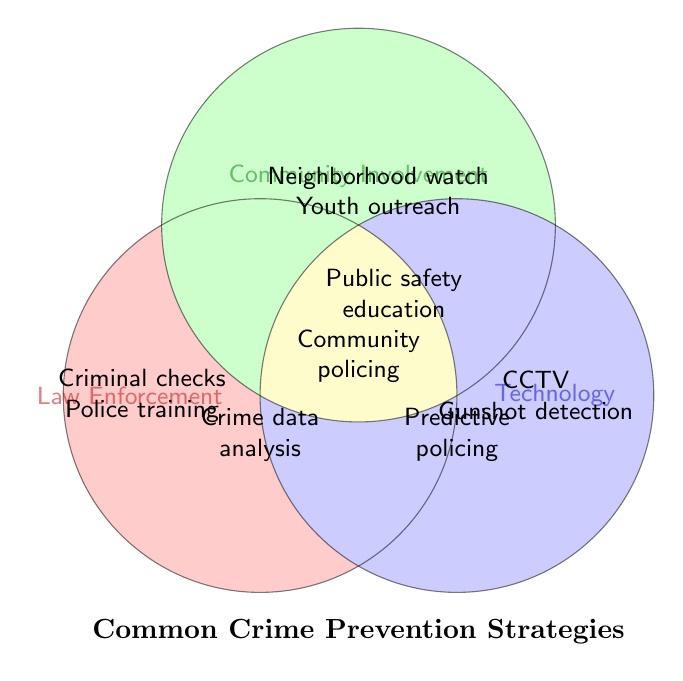What are the three main categories shown in the figure? The figure categorically divides common crime prevention strategies into three distinct areas: Law Enforcement, Community Involvement, and Technology. Each category is represented by a colored circle.
Answer: Law Enforcement, Community Involvement, Technology Which strategies are related to Law Enforcement? The strategies within the Law Enforcement circle are: Increased police patrols, Criminal record checks, Police training programs, Strict firearms licensing, and Crime data analysis.
Answer: Increased police patrols, Criminal record checks, Police training programs, Strict firearms licensing, Crime data analysis Which strategy overlaps between Law Enforcement and Community Involvement? The overlapping area between Law Enforcement and Community Involvement contains the strategy for Community policing initiatives.
Answer: Community policing initiatives What strategies fall under Community Involvement? The strategies within the Community Involvement circle are: Neighborhood watch programs, Community policing initiatives, Youth outreach programs, Public safety education, and Volunteer safety patrols.
Answer: Neighborhood watch programs, Community policing initiatives, Youth outreach programs, Public safety education, Volunteer safety patrols List the strategies that use Technology. The strategies within the Technology circle are: CCTV surveillance, Gunshot detection systems, Electronic monitoring of offenders, Predictive policing software, and Automated license plate readers.
Answer: CCTV surveillance, Gunshot detection systems, Electronic monitoring of offenders, Predictive policing software, Automated license plate readers Which strategies overlap between Technology and Law Enforcement? The overlapping strategies between Technology and Law Enforcement include Predictive policing software.
Answer: Predictive policing software Are there any strategies that fall within all three categories? The area where all three circles overlap contains the Crime data analysis strategy, which is relevant to Law Enforcement, Community Involvement, and Technology.
Answer: Crime data analysis How many strategies are there in the Community Involvement category alone? In the Community Involvement circle, excluding any overlaps with Law Enforcement or Technology, there are four strategies: Neighborhood watch programs, Youth outreach programs, Public safety education, and Volunteer safety patrols.
Answer: 4 Which strategies do Law Enforcement and Technology share? The overlapping area between Law Enforcement and Technology includes the strategies Predictive policing software and Crime data analysis.
Answer: Predictive policing software, Crime data analysis What strategy engages all three categories? The strategy that overlaps all three categories—Law Enforcement, Community Involvement, and Technology—is Crime data analysis.
Answer: Crime data analysis 